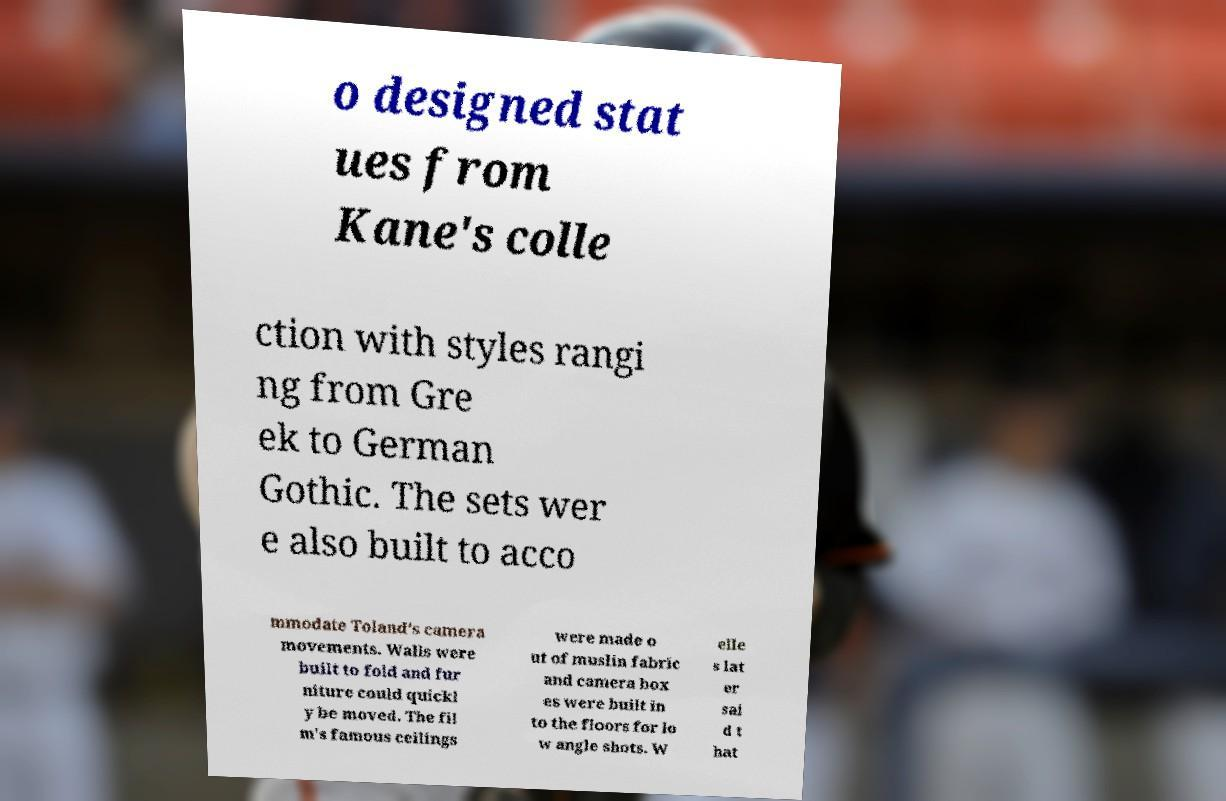There's text embedded in this image that I need extracted. Can you transcribe it verbatim? o designed stat ues from Kane's colle ction with styles rangi ng from Gre ek to German Gothic. The sets wer e also built to acco mmodate Toland's camera movements. Walls were built to fold and fur niture could quickl y be moved. The fil m's famous ceilings were made o ut of muslin fabric and camera box es were built in to the floors for lo w angle shots. W elle s lat er sai d t hat 